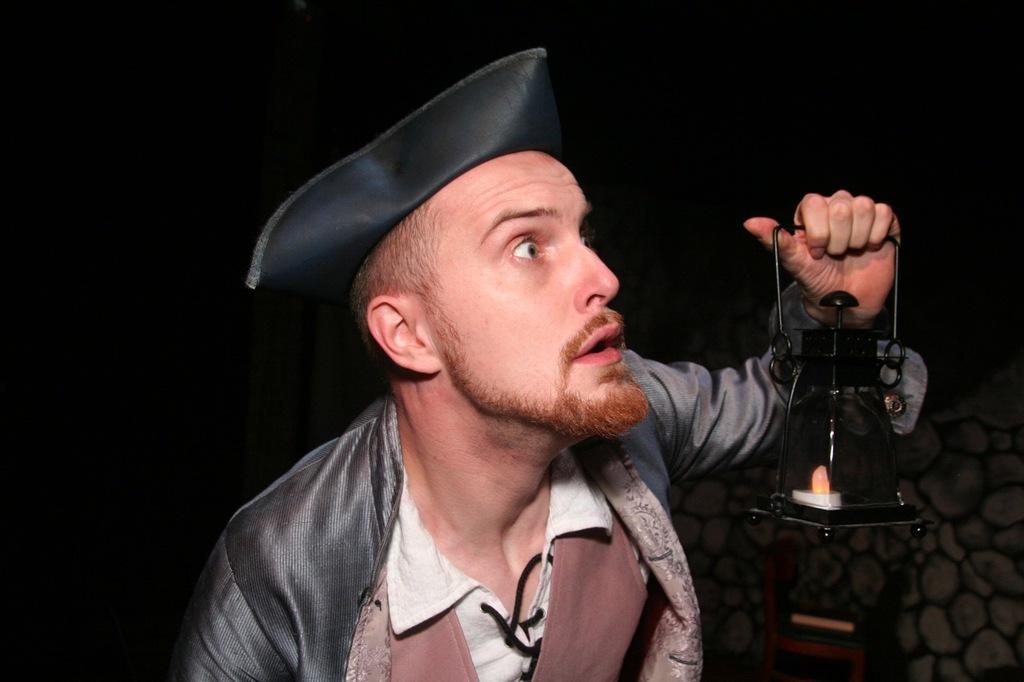Please provide a concise description of this image. There is a man holding lantern lamp and wire cap. On the background we can see wall. 